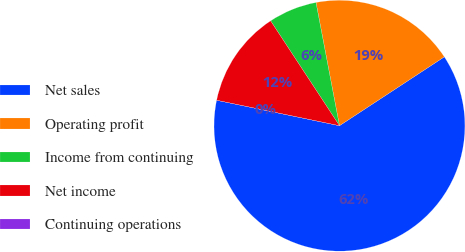Convert chart. <chart><loc_0><loc_0><loc_500><loc_500><pie_chart><fcel>Net sales<fcel>Operating profit<fcel>Income from continuing<fcel>Net income<fcel>Continuing operations<nl><fcel>62.5%<fcel>18.75%<fcel>6.25%<fcel>12.5%<fcel>0.0%<nl></chart> 